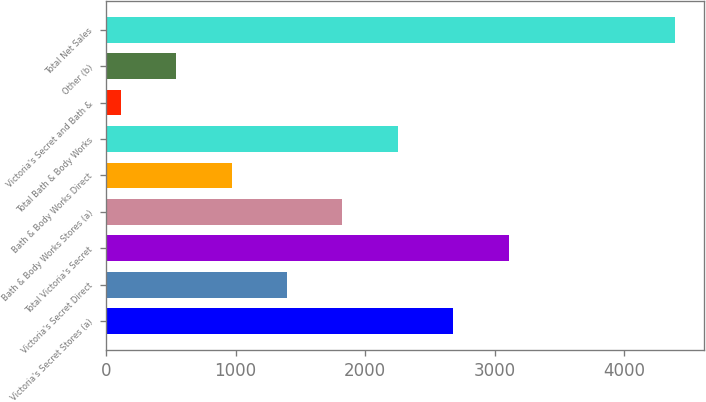<chart> <loc_0><loc_0><loc_500><loc_500><bar_chart><fcel>Victoria's Secret Stores (a)<fcel>Victoria's Secret Direct<fcel>Total Victoria's Secret<fcel>Bath & Body Works Stores (a)<fcel>Bath & Body Works Direct<fcel>Total Bath & Body Works<fcel>Victoria's Secret and Bath &<fcel>Other (b)<fcel>Total Net Sales<nl><fcel>2681.8<fcel>1396.9<fcel>3110.1<fcel>1825.2<fcel>968.6<fcel>2253.5<fcel>112<fcel>540.3<fcel>4395<nl></chart> 